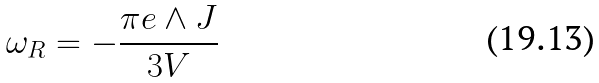<formula> <loc_0><loc_0><loc_500><loc_500>\omega _ { R } = - \frac { \pi e \wedge J } { 3 V }</formula> 